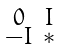<formula> <loc_0><loc_0><loc_500><loc_500>\begin{smallmatrix} 0 & I \\ - I & * \end{smallmatrix}</formula> 